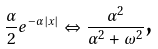<formula> <loc_0><loc_0><loc_500><loc_500>\frac { \alpha } { 2 } e ^ { - \alpha \left | x \right | } \Leftrightarrow \frac { \alpha ^ { 2 } } { \alpha ^ { 2 } + \omega ^ { 2 } } \text {,} \,</formula> 